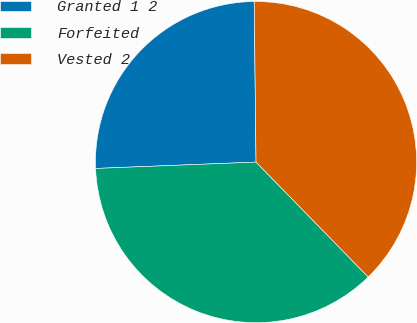<chart> <loc_0><loc_0><loc_500><loc_500><pie_chart><fcel>Granted 1 2<fcel>Forfeited<fcel>Vested 2<nl><fcel>25.45%<fcel>36.68%<fcel>37.88%<nl></chart> 